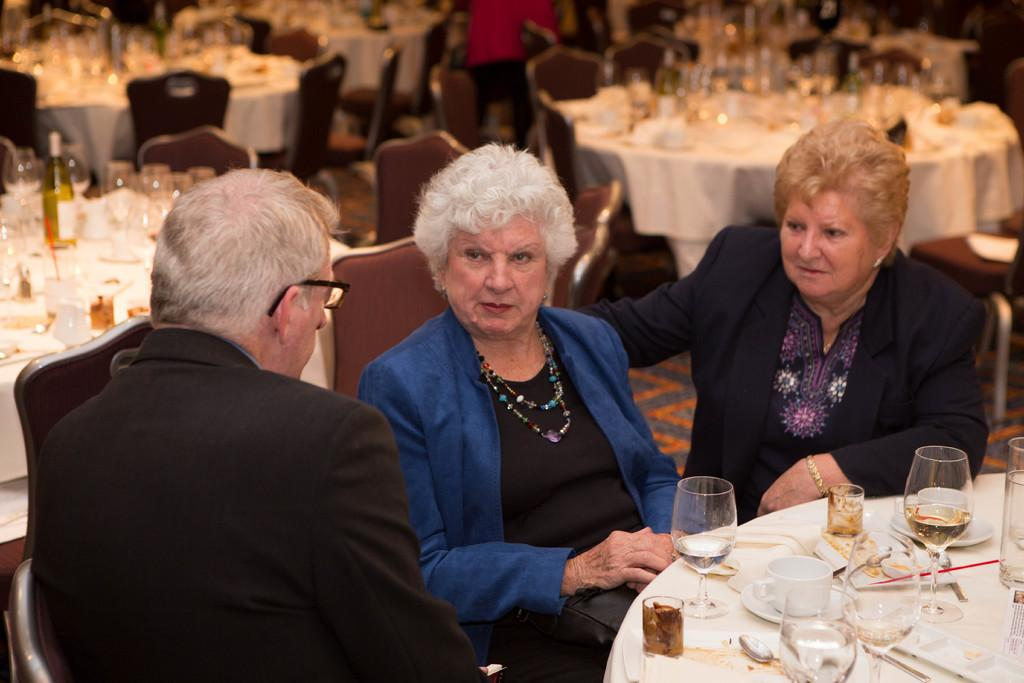What are the people in the image doing? The people in the image are sitting on chairs. What type of objects can be seen in the image? There are glasses, cups, saucers, spoons, and a bottle in the image. Are there any objects on the tables in the image? Yes, there are objects on the tables in the image. What can be seen in the background of the image? There are chairs and tables in the background of the image. What is the news being reported on the potato in the image? There is no potato or news being reported in the image. 